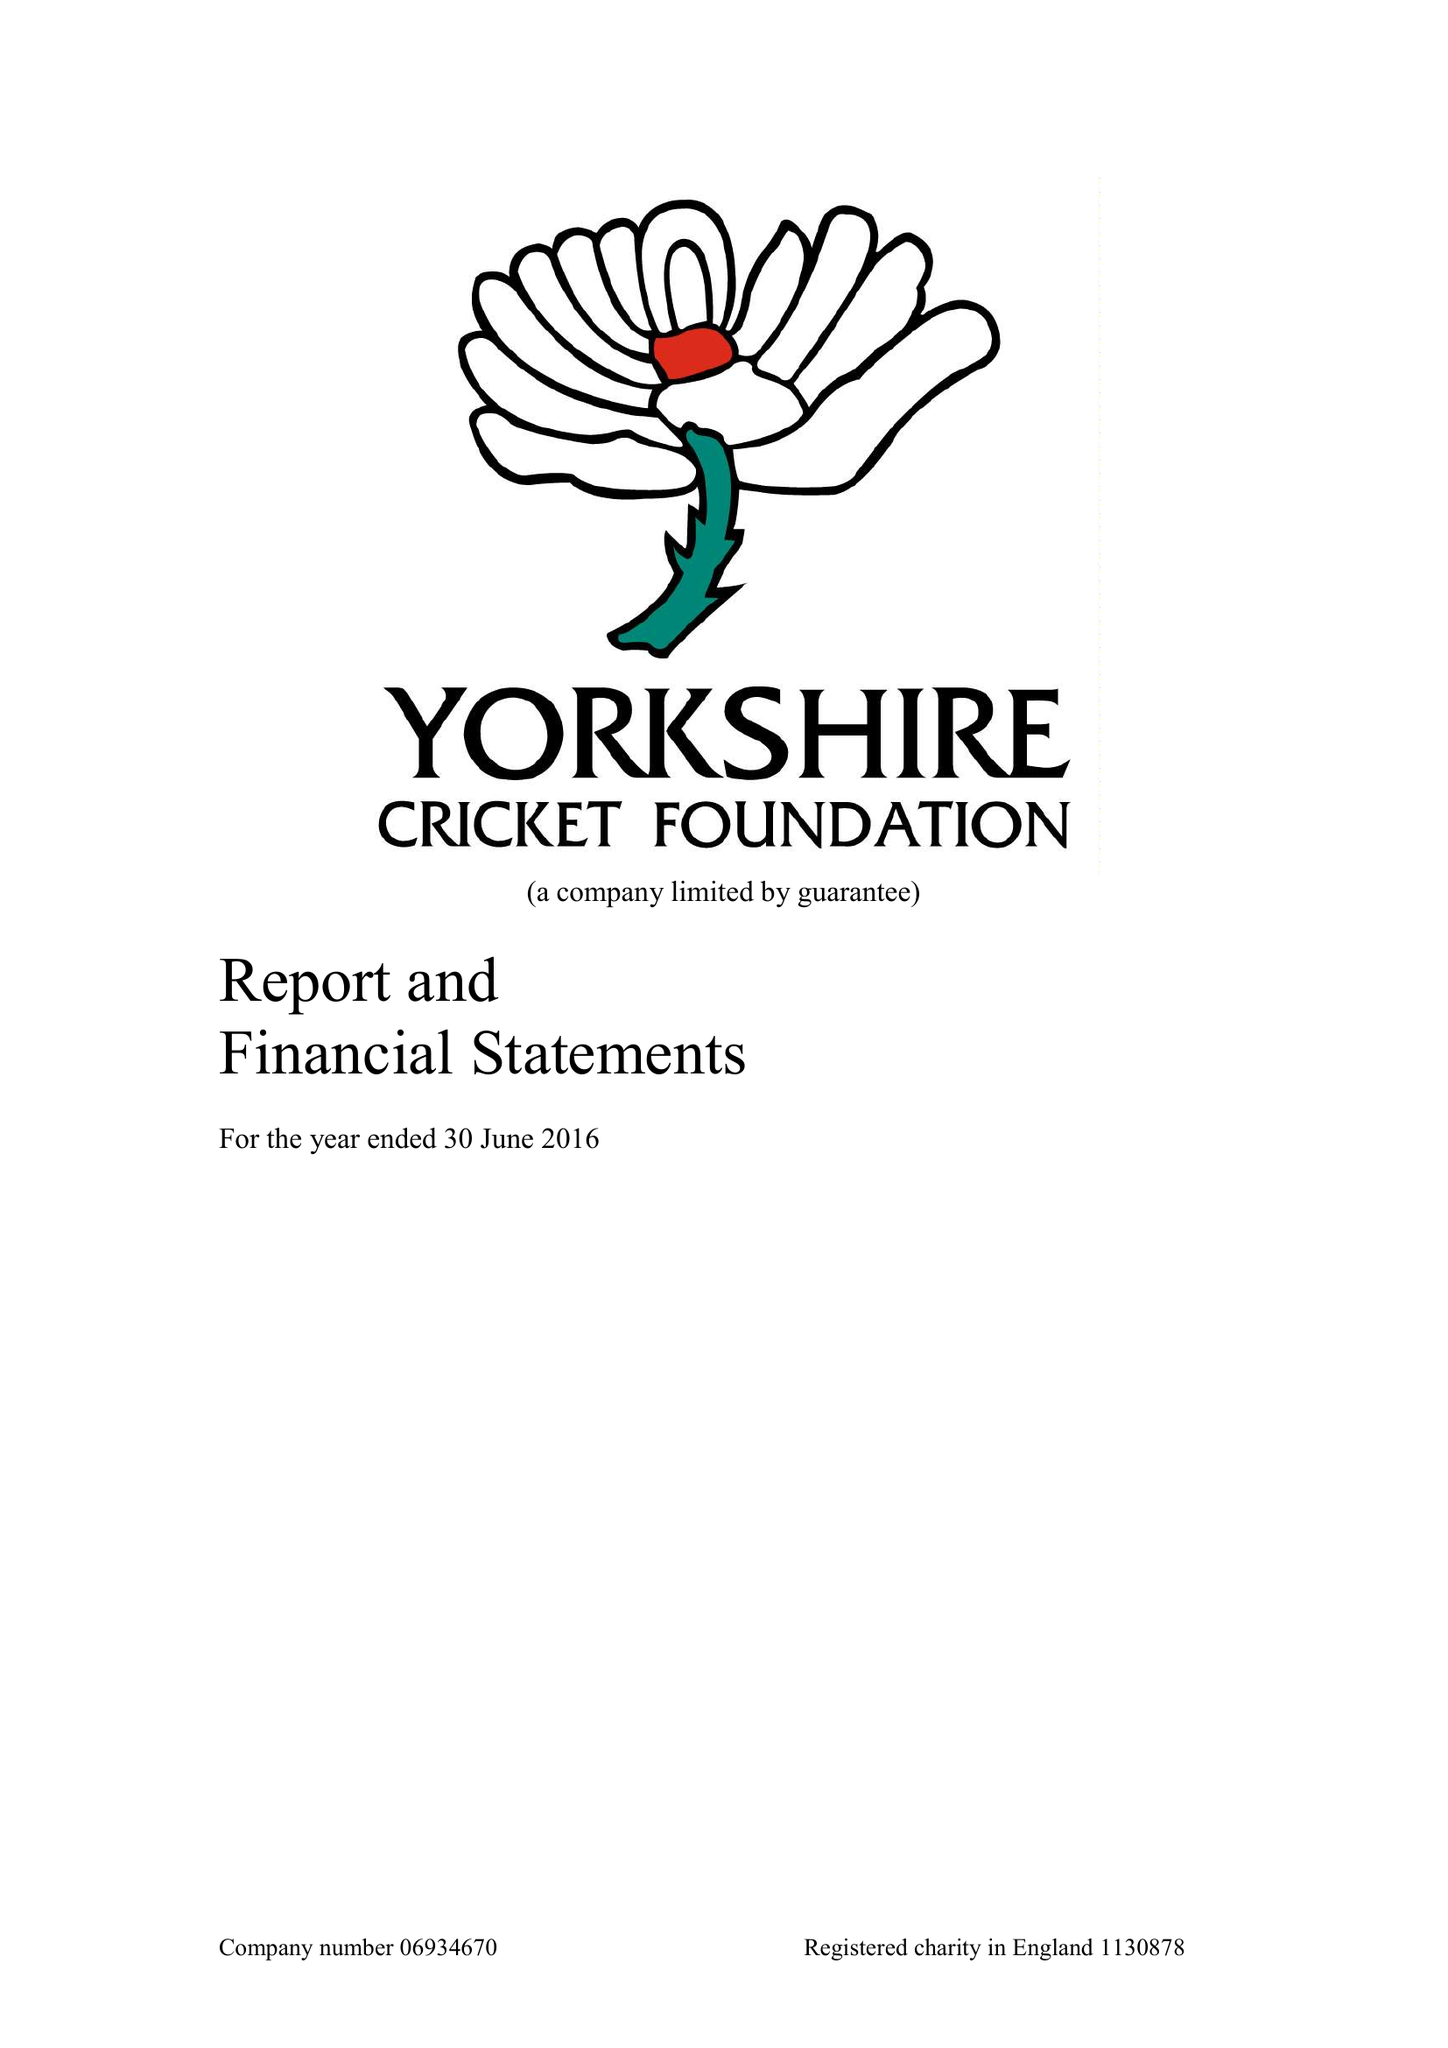What is the value for the address__post_town?
Answer the question using a single word or phrase. LEEDS 